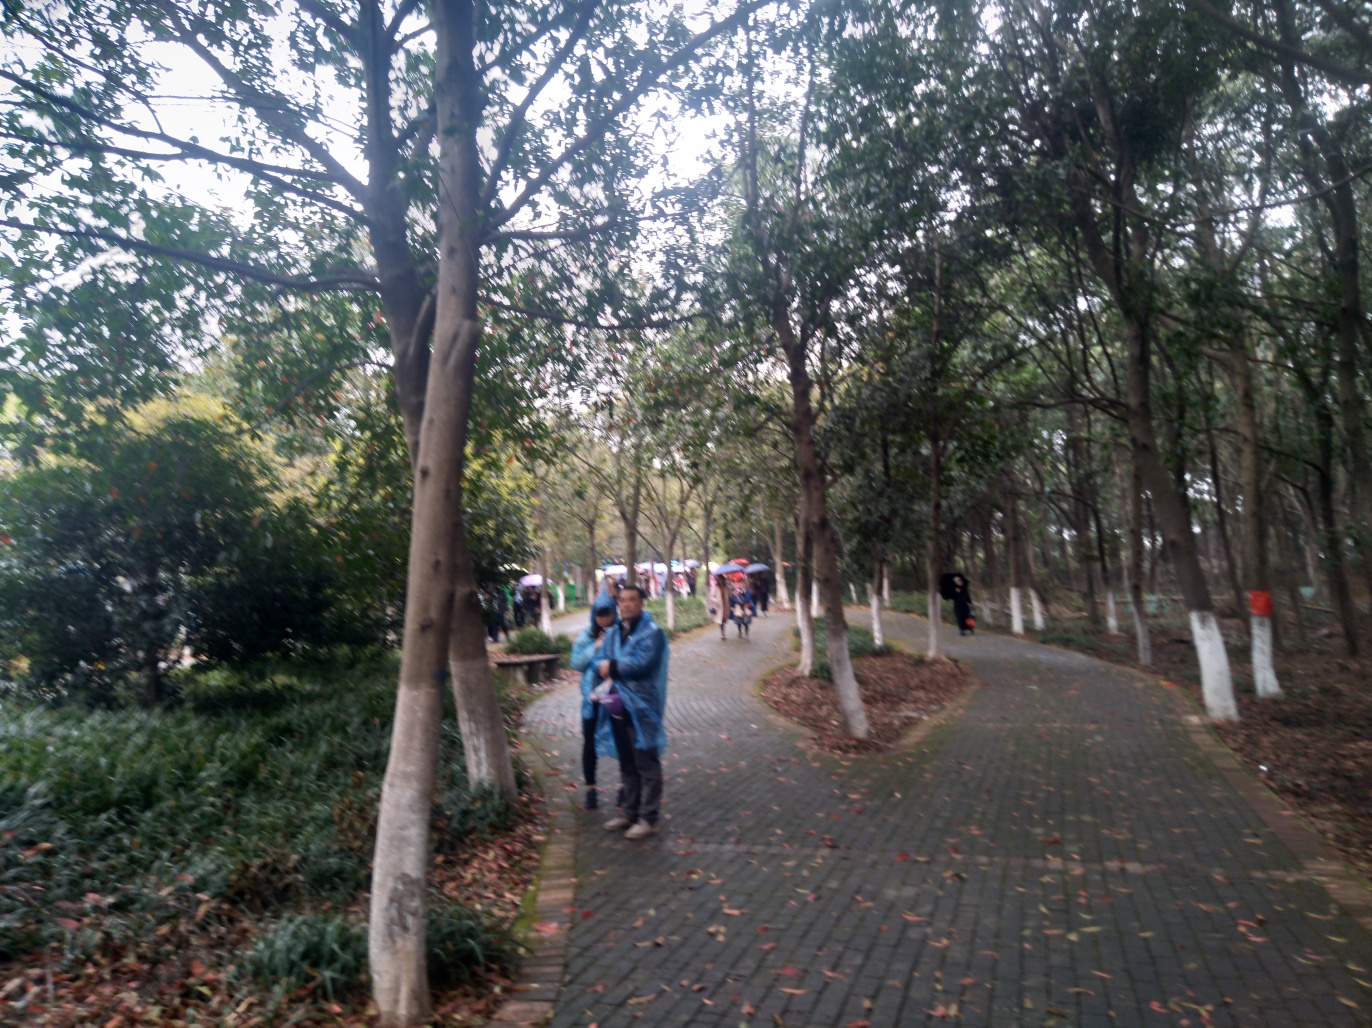What kind of activities can you infer are popular in this location based on the image? The image hints at a location that is suitable for various low-intensity, recreational activities. The presence of walking paths suggests that strolling or jogging might be popular here. The spacious areas between trees could be used for picnicking, quiet reading, or casual social gatherings. There don't seem to be any sports facilities directly visible, so it's likely that activities here are more focused on relaxation and enjoying the natural environment. 